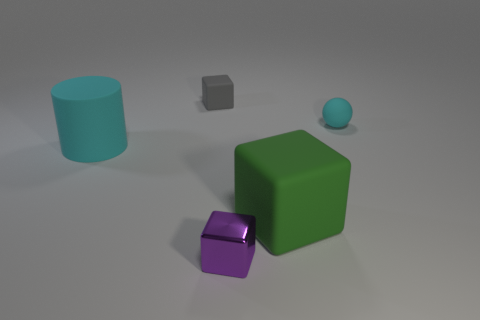There is a cyan thing in front of the cyan thing that is to the right of the small block that is in front of the rubber cylinder; what is it made of?
Offer a terse response. Rubber. There is a tiny thing in front of the green rubber block that is left of the tiny cyan sphere; what is it made of?
Your response must be concise. Metal. Is the size of the gray thing that is to the left of the tiny cyan rubber sphere the same as the purple object that is on the left side of the big green cube?
Make the answer very short. Yes. Is there any other thing that has the same material as the small gray object?
Give a very brief answer. Yes. What number of tiny objects are cyan objects or purple shiny objects?
Your response must be concise. 2. How many objects are either large things on the right side of the small shiny object or purple cubes?
Offer a very short reply. 2. Is the metallic block the same color as the large cylinder?
Your answer should be compact. No. What number of other things are there of the same shape as the gray rubber thing?
Offer a terse response. 2. What number of green objects are either tiny spheres or cubes?
Your response must be concise. 1. There is a sphere that is the same material as the large cyan object; what is its color?
Your answer should be very brief. Cyan. 